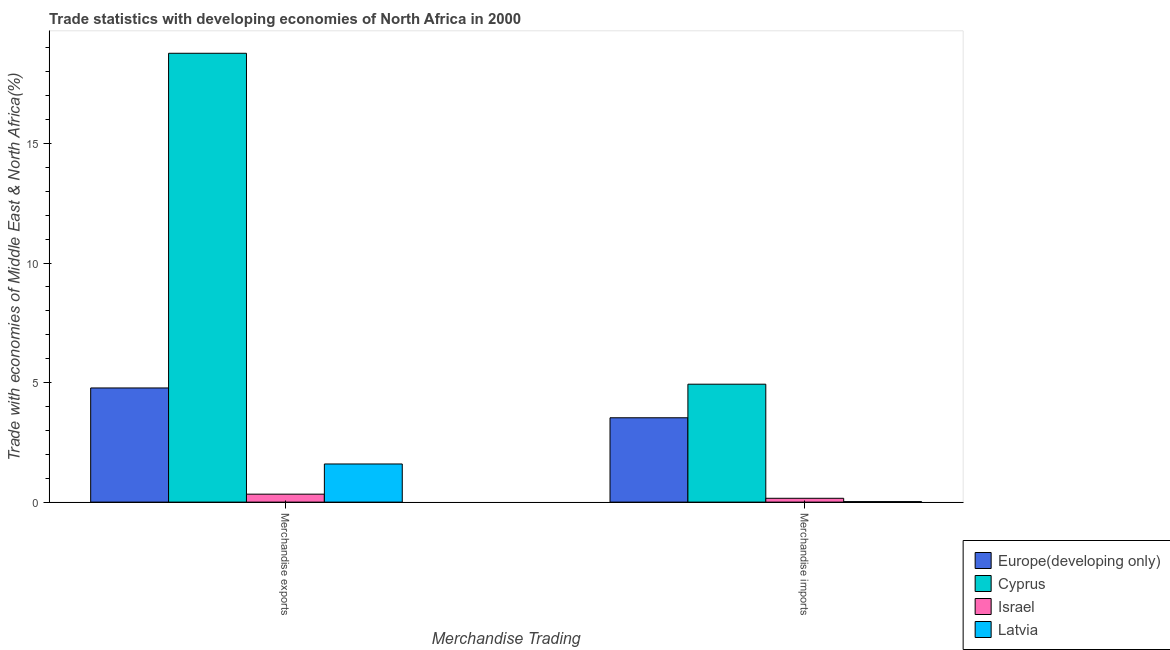How many groups of bars are there?
Ensure brevity in your answer.  2. Are the number of bars per tick equal to the number of legend labels?
Provide a succinct answer. Yes. Are the number of bars on each tick of the X-axis equal?
Your answer should be very brief. Yes. How many bars are there on the 1st tick from the left?
Provide a short and direct response. 4. How many bars are there on the 2nd tick from the right?
Offer a terse response. 4. What is the label of the 1st group of bars from the left?
Your response must be concise. Merchandise exports. What is the merchandise exports in Europe(developing only)?
Your answer should be compact. 4.78. Across all countries, what is the maximum merchandise imports?
Your answer should be very brief. 4.93. Across all countries, what is the minimum merchandise exports?
Your answer should be very brief. 0.33. In which country was the merchandise imports maximum?
Provide a succinct answer. Cyprus. In which country was the merchandise imports minimum?
Provide a short and direct response. Latvia. What is the total merchandise exports in the graph?
Ensure brevity in your answer.  25.48. What is the difference between the merchandise imports in Europe(developing only) and that in Cyprus?
Ensure brevity in your answer.  -1.4. What is the difference between the merchandise exports in Europe(developing only) and the merchandise imports in Latvia?
Offer a very short reply. 4.75. What is the average merchandise exports per country?
Your answer should be compact. 6.37. What is the difference between the merchandise exports and merchandise imports in Latvia?
Provide a short and direct response. 1.57. In how many countries, is the merchandise imports greater than 16 %?
Your response must be concise. 0. What is the ratio of the merchandise exports in Latvia to that in Cyprus?
Keep it short and to the point. 0.08. Is the merchandise exports in Europe(developing only) less than that in Latvia?
Ensure brevity in your answer.  No. What does the 1st bar from the left in Merchandise imports represents?
Offer a very short reply. Europe(developing only). What does the 1st bar from the right in Merchandise exports represents?
Provide a short and direct response. Latvia. How many countries are there in the graph?
Make the answer very short. 4. What is the difference between two consecutive major ticks on the Y-axis?
Make the answer very short. 5. Are the values on the major ticks of Y-axis written in scientific E-notation?
Give a very brief answer. No. Does the graph contain any zero values?
Offer a very short reply. No. Does the graph contain grids?
Provide a succinct answer. No. What is the title of the graph?
Your answer should be compact. Trade statistics with developing economies of North Africa in 2000. Does "Greece" appear as one of the legend labels in the graph?
Offer a terse response. No. What is the label or title of the X-axis?
Your answer should be very brief. Merchandise Trading. What is the label or title of the Y-axis?
Make the answer very short. Trade with economies of Middle East & North Africa(%). What is the Trade with economies of Middle East & North Africa(%) of Europe(developing only) in Merchandise exports?
Keep it short and to the point. 4.78. What is the Trade with economies of Middle East & North Africa(%) in Cyprus in Merchandise exports?
Your response must be concise. 18.78. What is the Trade with economies of Middle East & North Africa(%) of Israel in Merchandise exports?
Offer a terse response. 0.33. What is the Trade with economies of Middle East & North Africa(%) in Latvia in Merchandise exports?
Your answer should be very brief. 1.6. What is the Trade with economies of Middle East & North Africa(%) in Europe(developing only) in Merchandise imports?
Provide a succinct answer. 3.53. What is the Trade with economies of Middle East & North Africa(%) of Cyprus in Merchandise imports?
Provide a short and direct response. 4.93. What is the Trade with economies of Middle East & North Africa(%) in Israel in Merchandise imports?
Your answer should be very brief. 0.16. What is the Trade with economies of Middle East & North Africa(%) in Latvia in Merchandise imports?
Offer a very short reply. 0.02. Across all Merchandise Trading, what is the maximum Trade with economies of Middle East & North Africa(%) in Europe(developing only)?
Provide a succinct answer. 4.78. Across all Merchandise Trading, what is the maximum Trade with economies of Middle East & North Africa(%) of Cyprus?
Keep it short and to the point. 18.78. Across all Merchandise Trading, what is the maximum Trade with economies of Middle East & North Africa(%) in Israel?
Provide a succinct answer. 0.33. Across all Merchandise Trading, what is the maximum Trade with economies of Middle East & North Africa(%) in Latvia?
Provide a succinct answer. 1.6. Across all Merchandise Trading, what is the minimum Trade with economies of Middle East & North Africa(%) of Europe(developing only)?
Your answer should be compact. 3.53. Across all Merchandise Trading, what is the minimum Trade with economies of Middle East & North Africa(%) of Cyprus?
Offer a terse response. 4.93. Across all Merchandise Trading, what is the minimum Trade with economies of Middle East & North Africa(%) of Israel?
Provide a succinct answer. 0.16. Across all Merchandise Trading, what is the minimum Trade with economies of Middle East & North Africa(%) of Latvia?
Your answer should be compact. 0.02. What is the total Trade with economies of Middle East & North Africa(%) of Europe(developing only) in the graph?
Provide a succinct answer. 8.3. What is the total Trade with economies of Middle East & North Africa(%) in Cyprus in the graph?
Your response must be concise. 23.71. What is the total Trade with economies of Middle East & North Africa(%) in Israel in the graph?
Offer a very short reply. 0.49. What is the total Trade with economies of Middle East & North Africa(%) in Latvia in the graph?
Your response must be concise. 1.62. What is the difference between the Trade with economies of Middle East & North Africa(%) of Europe(developing only) in Merchandise exports and that in Merchandise imports?
Ensure brevity in your answer.  1.25. What is the difference between the Trade with economies of Middle East & North Africa(%) in Cyprus in Merchandise exports and that in Merchandise imports?
Offer a very short reply. 13.84. What is the difference between the Trade with economies of Middle East & North Africa(%) in Israel in Merchandise exports and that in Merchandise imports?
Provide a succinct answer. 0.17. What is the difference between the Trade with economies of Middle East & North Africa(%) of Latvia in Merchandise exports and that in Merchandise imports?
Ensure brevity in your answer.  1.57. What is the difference between the Trade with economies of Middle East & North Africa(%) of Europe(developing only) in Merchandise exports and the Trade with economies of Middle East & North Africa(%) of Cyprus in Merchandise imports?
Your answer should be compact. -0.16. What is the difference between the Trade with economies of Middle East & North Africa(%) in Europe(developing only) in Merchandise exports and the Trade with economies of Middle East & North Africa(%) in Israel in Merchandise imports?
Offer a very short reply. 4.62. What is the difference between the Trade with economies of Middle East & North Africa(%) in Europe(developing only) in Merchandise exports and the Trade with economies of Middle East & North Africa(%) in Latvia in Merchandise imports?
Offer a very short reply. 4.75. What is the difference between the Trade with economies of Middle East & North Africa(%) of Cyprus in Merchandise exports and the Trade with economies of Middle East & North Africa(%) of Israel in Merchandise imports?
Make the answer very short. 18.62. What is the difference between the Trade with economies of Middle East & North Africa(%) of Cyprus in Merchandise exports and the Trade with economies of Middle East & North Africa(%) of Latvia in Merchandise imports?
Ensure brevity in your answer.  18.75. What is the difference between the Trade with economies of Middle East & North Africa(%) in Israel in Merchandise exports and the Trade with economies of Middle East & North Africa(%) in Latvia in Merchandise imports?
Ensure brevity in your answer.  0.31. What is the average Trade with economies of Middle East & North Africa(%) of Europe(developing only) per Merchandise Trading?
Offer a terse response. 4.15. What is the average Trade with economies of Middle East & North Africa(%) in Cyprus per Merchandise Trading?
Keep it short and to the point. 11.85. What is the average Trade with economies of Middle East & North Africa(%) of Israel per Merchandise Trading?
Keep it short and to the point. 0.25. What is the average Trade with economies of Middle East & North Africa(%) of Latvia per Merchandise Trading?
Make the answer very short. 0.81. What is the difference between the Trade with economies of Middle East & North Africa(%) of Europe(developing only) and Trade with economies of Middle East & North Africa(%) of Cyprus in Merchandise exports?
Make the answer very short. -14. What is the difference between the Trade with economies of Middle East & North Africa(%) of Europe(developing only) and Trade with economies of Middle East & North Africa(%) of Israel in Merchandise exports?
Offer a terse response. 4.44. What is the difference between the Trade with economies of Middle East & North Africa(%) in Europe(developing only) and Trade with economies of Middle East & North Africa(%) in Latvia in Merchandise exports?
Give a very brief answer. 3.18. What is the difference between the Trade with economies of Middle East & North Africa(%) of Cyprus and Trade with economies of Middle East & North Africa(%) of Israel in Merchandise exports?
Provide a short and direct response. 18.44. What is the difference between the Trade with economies of Middle East & North Africa(%) of Cyprus and Trade with economies of Middle East & North Africa(%) of Latvia in Merchandise exports?
Your answer should be very brief. 17.18. What is the difference between the Trade with economies of Middle East & North Africa(%) in Israel and Trade with economies of Middle East & North Africa(%) in Latvia in Merchandise exports?
Ensure brevity in your answer.  -1.26. What is the difference between the Trade with economies of Middle East & North Africa(%) in Europe(developing only) and Trade with economies of Middle East & North Africa(%) in Cyprus in Merchandise imports?
Keep it short and to the point. -1.4. What is the difference between the Trade with economies of Middle East & North Africa(%) of Europe(developing only) and Trade with economies of Middle East & North Africa(%) of Israel in Merchandise imports?
Keep it short and to the point. 3.37. What is the difference between the Trade with economies of Middle East & North Africa(%) in Europe(developing only) and Trade with economies of Middle East & North Africa(%) in Latvia in Merchandise imports?
Offer a very short reply. 3.51. What is the difference between the Trade with economies of Middle East & North Africa(%) of Cyprus and Trade with economies of Middle East & North Africa(%) of Israel in Merchandise imports?
Keep it short and to the point. 4.77. What is the difference between the Trade with economies of Middle East & North Africa(%) in Cyprus and Trade with economies of Middle East & North Africa(%) in Latvia in Merchandise imports?
Give a very brief answer. 4.91. What is the difference between the Trade with economies of Middle East & North Africa(%) in Israel and Trade with economies of Middle East & North Africa(%) in Latvia in Merchandise imports?
Provide a short and direct response. 0.14. What is the ratio of the Trade with economies of Middle East & North Africa(%) of Europe(developing only) in Merchandise exports to that in Merchandise imports?
Keep it short and to the point. 1.35. What is the ratio of the Trade with economies of Middle East & North Africa(%) in Cyprus in Merchandise exports to that in Merchandise imports?
Provide a short and direct response. 3.81. What is the ratio of the Trade with economies of Middle East & North Africa(%) in Israel in Merchandise exports to that in Merchandise imports?
Keep it short and to the point. 2.08. What is the ratio of the Trade with economies of Middle East & North Africa(%) of Latvia in Merchandise exports to that in Merchandise imports?
Provide a short and direct response. 75.71. What is the difference between the highest and the second highest Trade with economies of Middle East & North Africa(%) in Europe(developing only)?
Keep it short and to the point. 1.25. What is the difference between the highest and the second highest Trade with economies of Middle East & North Africa(%) in Cyprus?
Offer a terse response. 13.84. What is the difference between the highest and the second highest Trade with economies of Middle East & North Africa(%) of Israel?
Your response must be concise. 0.17. What is the difference between the highest and the second highest Trade with economies of Middle East & North Africa(%) in Latvia?
Your response must be concise. 1.57. What is the difference between the highest and the lowest Trade with economies of Middle East & North Africa(%) in Europe(developing only)?
Offer a very short reply. 1.25. What is the difference between the highest and the lowest Trade with economies of Middle East & North Africa(%) of Cyprus?
Offer a very short reply. 13.84. What is the difference between the highest and the lowest Trade with economies of Middle East & North Africa(%) of Israel?
Your answer should be very brief. 0.17. What is the difference between the highest and the lowest Trade with economies of Middle East & North Africa(%) of Latvia?
Your answer should be compact. 1.57. 